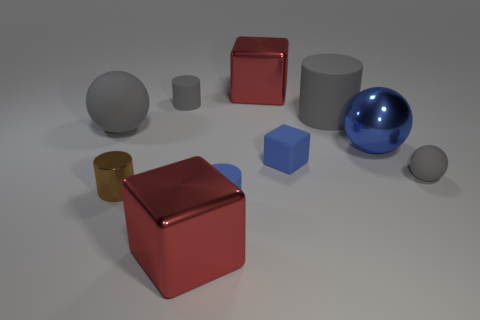The tiny rubber ball has what color?
Provide a short and direct response. Gray. How many balls have the same material as the small brown cylinder?
Ensure brevity in your answer.  1. There is a sphere that is the same material as the brown object; what color is it?
Give a very brief answer. Blue. What shape is the blue shiny object?
Give a very brief answer. Sphere. What number of tiny matte blocks are the same color as the metal sphere?
Ensure brevity in your answer.  1. There is a blue object that is the same size as the blue block; what is its shape?
Your answer should be very brief. Cylinder. Are there any cylinders of the same size as the blue metal ball?
Offer a terse response. Yes. There is a brown thing that is the same size as the matte block; what is it made of?
Provide a succinct answer. Metal. What size is the shiny sphere that is on the right side of the large gray rubber ball to the left of the tiny matte sphere?
Make the answer very short. Large. Do the matte thing in front of the brown cylinder and the brown cylinder have the same size?
Provide a short and direct response. Yes. 